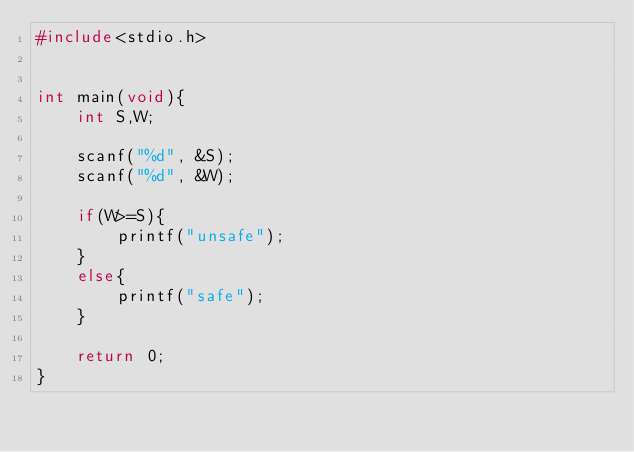<code> <loc_0><loc_0><loc_500><loc_500><_C_>#include<stdio.h>


int main(void){
    int S,W;

    scanf("%d", &S);
    scanf("%d", &W);

    if(W>=S){
        printf("unsafe");
    }
    else{
        printf("safe");
    }

    return 0;
}</code> 